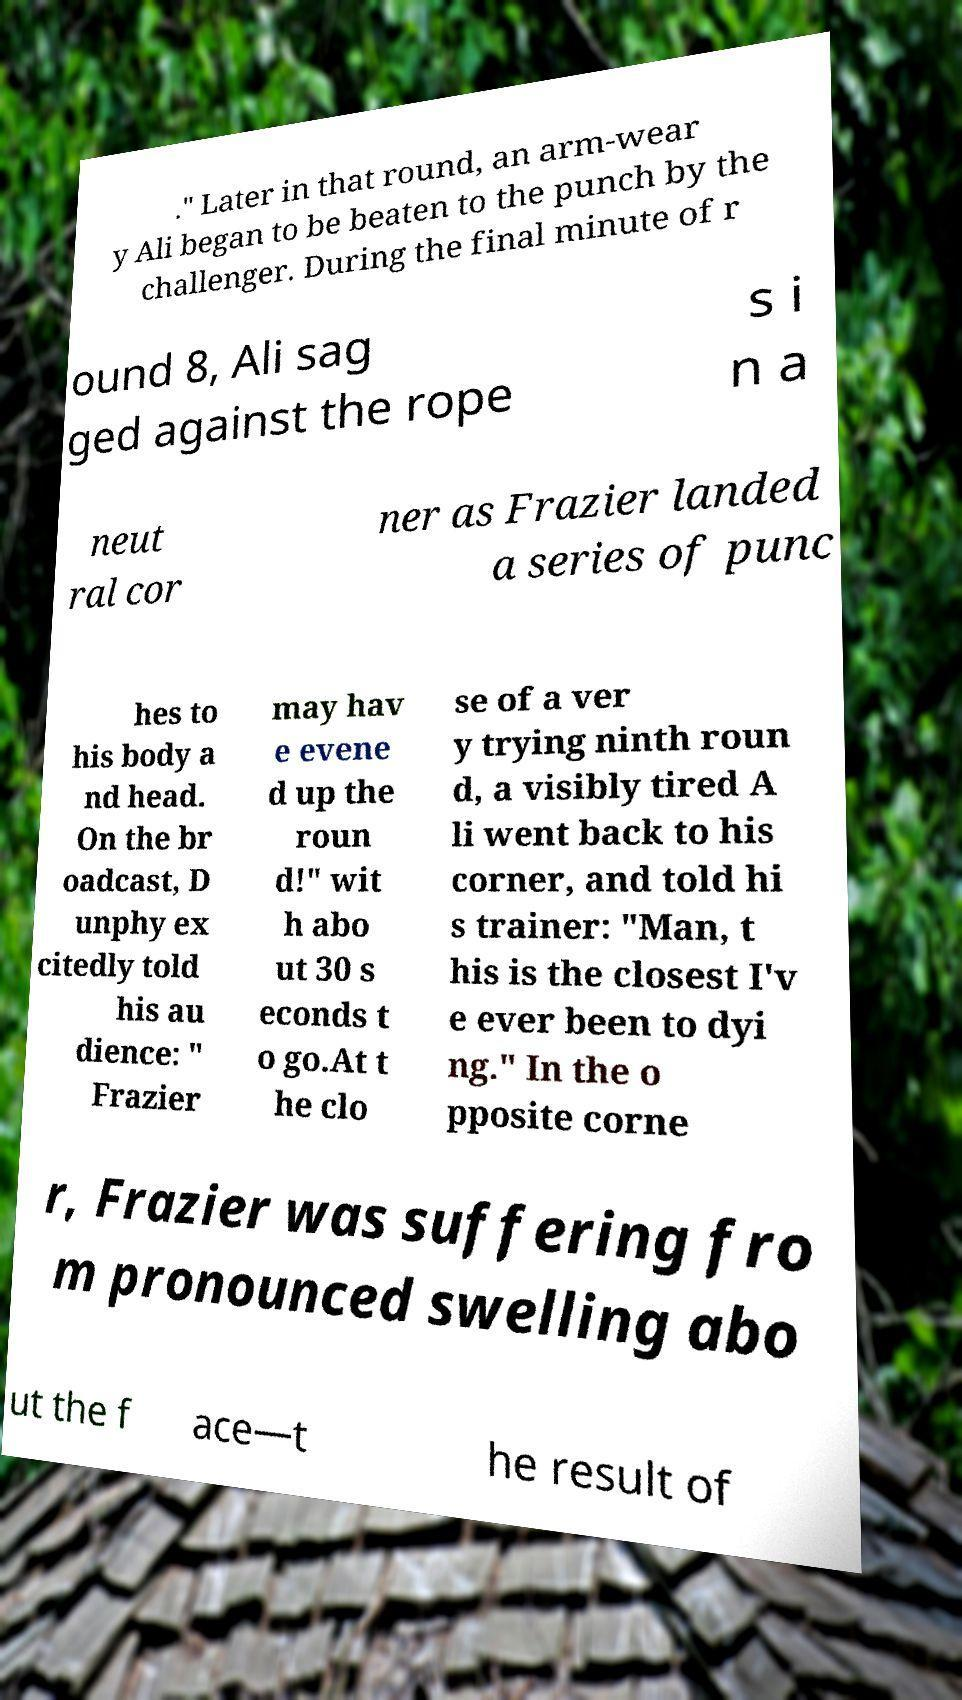I need the written content from this picture converted into text. Can you do that? ." Later in that round, an arm-wear y Ali began to be beaten to the punch by the challenger. During the final minute of r ound 8, Ali sag ged against the rope s i n a neut ral cor ner as Frazier landed a series of punc hes to his body a nd head. On the br oadcast, D unphy ex citedly told his au dience: " Frazier may hav e evene d up the roun d!" wit h abo ut 30 s econds t o go.At t he clo se of a ver y trying ninth roun d, a visibly tired A li went back to his corner, and told hi s trainer: "Man, t his is the closest I'v e ever been to dyi ng." In the o pposite corne r, Frazier was suffering fro m pronounced swelling abo ut the f ace—t he result of 